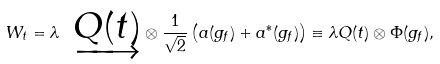<formula> <loc_0><loc_0><loc_500><loc_500>W _ { t } = \lambda \ \underrightarrow { Q ( t ) } \otimes \frac { 1 } { \sqrt { 2 } } \left ( a ( g _ { f } ) + a ^ { \ast } ( g _ { f } ) \right ) \equiv \lambda Q ( t ) \otimes \Phi ( g _ { f } ) ,</formula> 